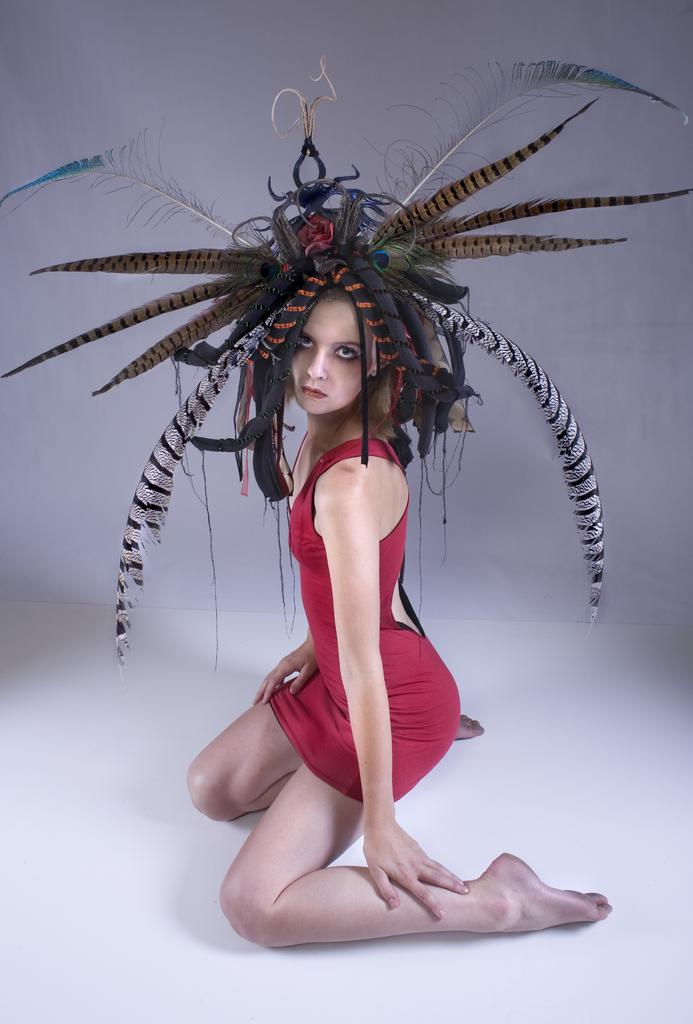What is the main subject of the image? There is a person in the image. Can you describe any unique features of the person? The person has decorations on their head. What else can be seen in the image besides the person? There are decorations on the wall in the image. What type of whip is being used by the person in the image? There is no whip present in the image. Can you describe the crow that is perched on the person's shoulder in the image? There is no crow present in the image. 